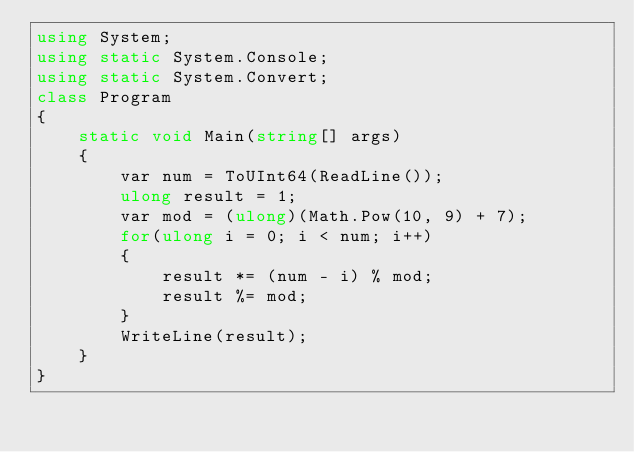Convert code to text. <code><loc_0><loc_0><loc_500><loc_500><_C#_>using System;
using static System.Console;
using static System.Convert;
class Program
{
    static void Main(string[] args)
    {
        var num = ToUInt64(ReadLine());
        ulong result = 1;
        var mod = (ulong)(Math.Pow(10, 9) + 7);
        for(ulong i = 0; i < num; i++)
        {
            result *= (num - i) % mod;
            result %= mod;
        }
        WriteLine(result);
    }
}</code> 